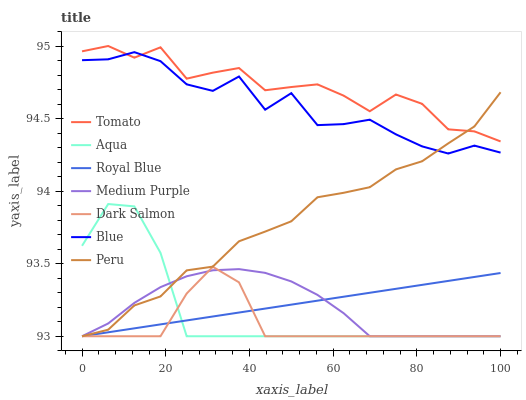Does Dark Salmon have the minimum area under the curve?
Answer yes or no. Yes. Does Tomato have the maximum area under the curve?
Answer yes or no. Yes. Does Blue have the minimum area under the curve?
Answer yes or no. No. Does Blue have the maximum area under the curve?
Answer yes or no. No. Is Royal Blue the smoothest?
Answer yes or no. Yes. Is Blue the roughest?
Answer yes or no. Yes. Is Aqua the smoothest?
Answer yes or no. No. Is Aqua the roughest?
Answer yes or no. No. Does Blue have the lowest value?
Answer yes or no. No. Does Tomato have the highest value?
Answer yes or no. Yes. Does Blue have the highest value?
Answer yes or no. No. Is Aqua less than Blue?
Answer yes or no. Yes. Is Blue greater than Aqua?
Answer yes or no. Yes. Does Royal Blue intersect Aqua?
Answer yes or no. Yes. Is Royal Blue less than Aqua?
Answer yes or no. No. Is Royal Blue greater than Aqua?
Answer yes or no. No. Does Aqua intersect Blue?
Answer yes or no. No. 